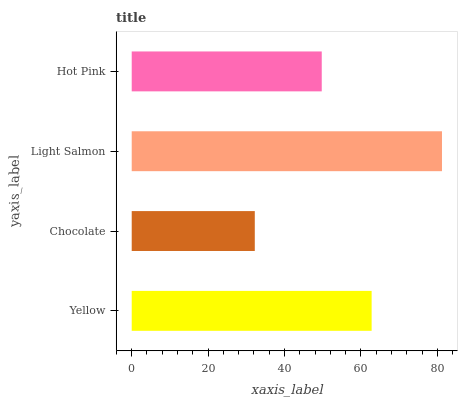Is Chocolate the minimum?
Answer yes or no. Yes. Is Light Salmon the maximum?
Answer yes or no. Yes. Is Light Salmon the minimum?
Answer yes or no. No. Is Chocolate the maximum?
Answer yes or no. No. Is Light Salmon greater than Chocolate?
Answer yes or no. Yes. Is Chocolate less than Light Salmon?
Answer yes or no. Yes. Is Chocolate greater than Light Salmon?
Answer yes or no. No. Is Light Salmon less than Chocolate?
Answer yes or no. No. Is Yellow the high median?
Answer yes or no. Yes. Is Hot Pink the low median?
Answer yes or no. Yes. Is Light Salmon the high median?
Answer yes or no. No. Is Chocolate the low median?
Answer yes or no. No. 